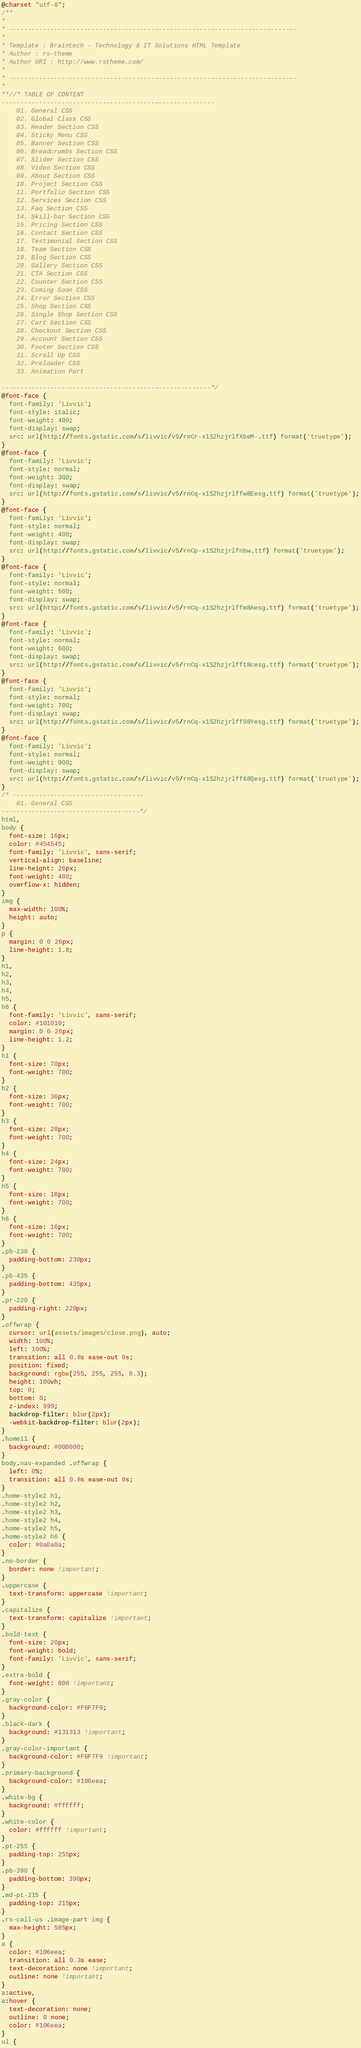Convert code to text. <code><loc_0><loc_0><loc_500><loc_500><_CSS_>@charset "utf-8";
/** 
* 
* -----------------------------------------------------------------------------
*
* Template : Braintech - Technology & IT Solutions HTML Template
* Author : rs-theme
* Author URI : http://www.rstheme.com/ 
*
* -----------------------------------------------------------------------------
* 
**//* TABLE OF CONTENT
---------------------------------------------------------
    01. General CSS
    02. Global Class CSS
    03. Header Section CSS
    04. Sticky Menu CSS
    05. Banner Section CSS
    06. Breadcrumbs Section CSS
    07. Slider Section CSS
    08. Video Section CSS
    09. About Section CSS
    10. Project Section CSS
    11. Portfolio Section CSS
    12. Services Section CSS
    13. Faq Section CSS
    14. Skill-bar Section CSS
    15. Pricing Section CSS
    16. Contact Section CSS
    17. Testimonial Section CSS
    18. Team Section CSS
    19. Blog Section CSS
    20. Gallery Section CSS
    21. CTA Section CSS
    22. Counter Section CSS
    23. Coming Soon CSS
    24. Error Section CSS
    25. Shop Section CSS
    26. Single Shop Section CSS
    27. Cart Section CSS
    28. Checkout Section CSS
    29. Account Section CSS
    30. Footer Section CSS
    31. Scroll Up CSS
    32. Preloader CSS
    33. Animation Part 

--------------------------------------------------------*/
@font-face {
  font-family: 'Livvic';
  font-style: italic;
  font-weight: 400;
  font-display: swap;
  src: url(http://fonts.gstatic.com/s/livvic/v5/rnCr-x1S2hzjrlfXbeM-.ttf) format('truetype');
}
@font-face {
  font-family: 'Livvic';
  font-style: normal;
  font-weight: 300;
  font-display: swap;
  src: url(http://fonts.gstatic.com/s/livvic/v5/rnCq-x1S2hzjrlffw8Eesg.ttf) format('truetype');
}
@font-face {
  font-family: 'Livvic';
  font-style: normal;
  font-weight: 400;
  font-display: swap;
  src: url(http://fonts.gstatic.com/s/livvic/v5/rnCp-x1S2hzjrlfnbw.ttf) format('truetype');
}
@font-face {
  font-family: 'Livvic';
  font-style: normal;
  font-weight: 500;
  font-display: swap;
  src: url(http://fonts.gstatic.com/s/livvic/v5/rnCq-x1S2hzjrlffm8Aesg.ttf) format('truetype');
}
@font-face {
  font-family: 'Livvic';
  font-style: normal;
  font-weight: 600;
  font-display: swap;
  src: url(http://fonts.gstatic.com/s/livvic/v5/rnCq-x1S2hzjrlfft8cesg.ttf) format('truetype');
}
@font-face {
  font-family: 'Livvic';
  font-style: normal;
  font-weight: 700;
  font-display: swap;
  src: url(http://fonts.gstatic.com/s/livvic/v5/rnCq-x1S2hzjrlff08Yesg.ttf) format('truetype');
}
@font-face {
  font-family: 'Livvic';
  font-style: normal;
  font-weight: 900;
  font-display: swap;
  src: url(http://fonts.gstatic.com/s/livvic/v5/rnCq-x1S2hzjrlff68Qesg.ttf) format('truetype');
}
/* -----------------------------------
    01. General CSS
-------------------------------------*/
html,
body {
  font-size: 16px;
  color: #454545;
  font-family: 'Livvic', sans-serif;
  vertical-align: baseline;
  line-height: 26px;
  font-weight: 400;
  overflow-x: hidden;
}
img {
  max-width: 100%;
  height: auto;
}
p {
  margin: 0 0 26px;
  line-height: 1.8;
}
h1,
h2,
h3,
h4,
h5,
h6 {
  font-family: 'Livvic', sans-serif;
  color: #101010;
  margin: 0 0 26px;
  line-height: 1.2;
}
h1 {
  font-size: 70px;
  font-weight: 700;
}
h2 {
  font-size: 36px;
  font-weight: 700;
}
h3 {
  font-size: 28px;
  font-weight: 700;
}
h4 {
  font-size: 24px;
  font-weight: 700;
}
h5 {
  font-size: 18px;
  font-weight: 700;
}
h6 {
  font-size: 16px;
  font-weight: 700;
}
.pb-230 {
  padding-bottom: 230px;
}
.pb-435 {
  padding-bottom: 435px;
}
.pr-220 {
  padding-right: 220px;
}
.offwrap {
  cursor: url(assets/images/close.png), auto;
  width: 100%;
  left: 100%;
  transition: all 0.8s ease-out 0s;
  position: fixed;
  background: rgba(255, 255, 255, 0.3);
  height: 100vh;
  top: 0;
  bottom: 0;
  z-index: 999;
  backdrop-filter: blur(2px);
  -webkit-backdrop-filter: blur(2px);
}
.home11 {
  background: #000000;
}
body.nav-expanded .offwrap {
  left: 0%;
  transition: all 0.8s ease-out 0s;
}
.home-style2 h1,
.home-style2 h2,
.home-style2 h3,
.home-style2 h4,
.home-style2 h5,
.home-style2 h6 {
  color: #0a0a0a;
}
.no-border {
  border: none !important;
}
.uppercase {
  text-transform: uppercase !important;
}
.capitalize {
  text-transform: capitalize !important;
}
.bold-text {
  font-size: 20px;
  font-weight: bold;
  font-family: 'Livvic', sans-serif;
}
.extra-bold {
  font-weight: 800 !important;
}
.gray-color {
  background-color: #F6F7F9;
}
.black-dark {
  background: #131313 !important;
}
.gray-color-important {
  background-color: #F6F7F9 !important;
}
.primary-background {
  background-color: #106eea;
}
.white-bg {
  background: #ffffff;
}
.white-color {
  color: #ffffff !important;
}
.pt-255 {
  padding-top: 255px;
}
.pb-390 {
  padding-bottom: 390px;
}
.md-pt-215 {
  padding-top: 215px;
}
.rs-call-us .image-part img {
  max-height: 585px;
}
a {
  color: #106eea;
  transition: all 0.3s ease;
  text-decoration: none !important;
  outline: none !important;
}
a:active,
a:hover {
  text-decoration: none;
  outline: 0 none;
  color: #106eea;
}
ul {</code> 